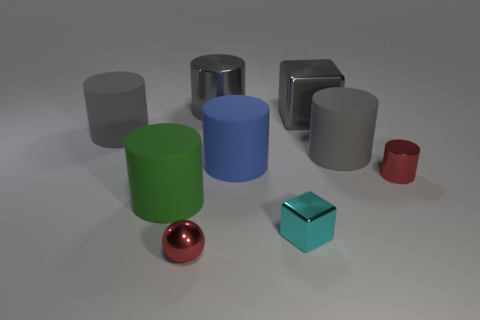How many big green rubber objects have the same shape as the blue thing?
Make the answer very short. 1. Is the number of big cubes that are to the right of the red shiny cylinder the same as the number of large gray rubber things?
Your answer should be very brief. No. What number of other things are the same color as the small shiny cylinder?
Your answer should be very brief. 1. What is the color of the matte object that is both on the left side of the gray cube and to the right of the metallic ball?
Offer a very short reply. Blue. What is the size of the metal block in front of the gray rubber object that is in front of the gray rubber cylinder that is left of the big shiny cylinder?
Give a very brief answer. Small. What number of things are either red objects to the right of the small metallic block or small metal objects behind the green cylinder?
Make the answer very short. 1. What is the shape of the tiny cyan object?
Offer a very short reply. Cube. What number of other objects are the same material as the big green object?
Ensure brevity in your answer.  3. What size is the gray metal thing that is the same shape as the cyan object?
Keep it short and to the point. Large. What material is the block behind the red shiny thing that is right of the gray rubber cylinder on the right side of the tiny red sphere made of?
Ensure brevity in your answer.  Metal. 